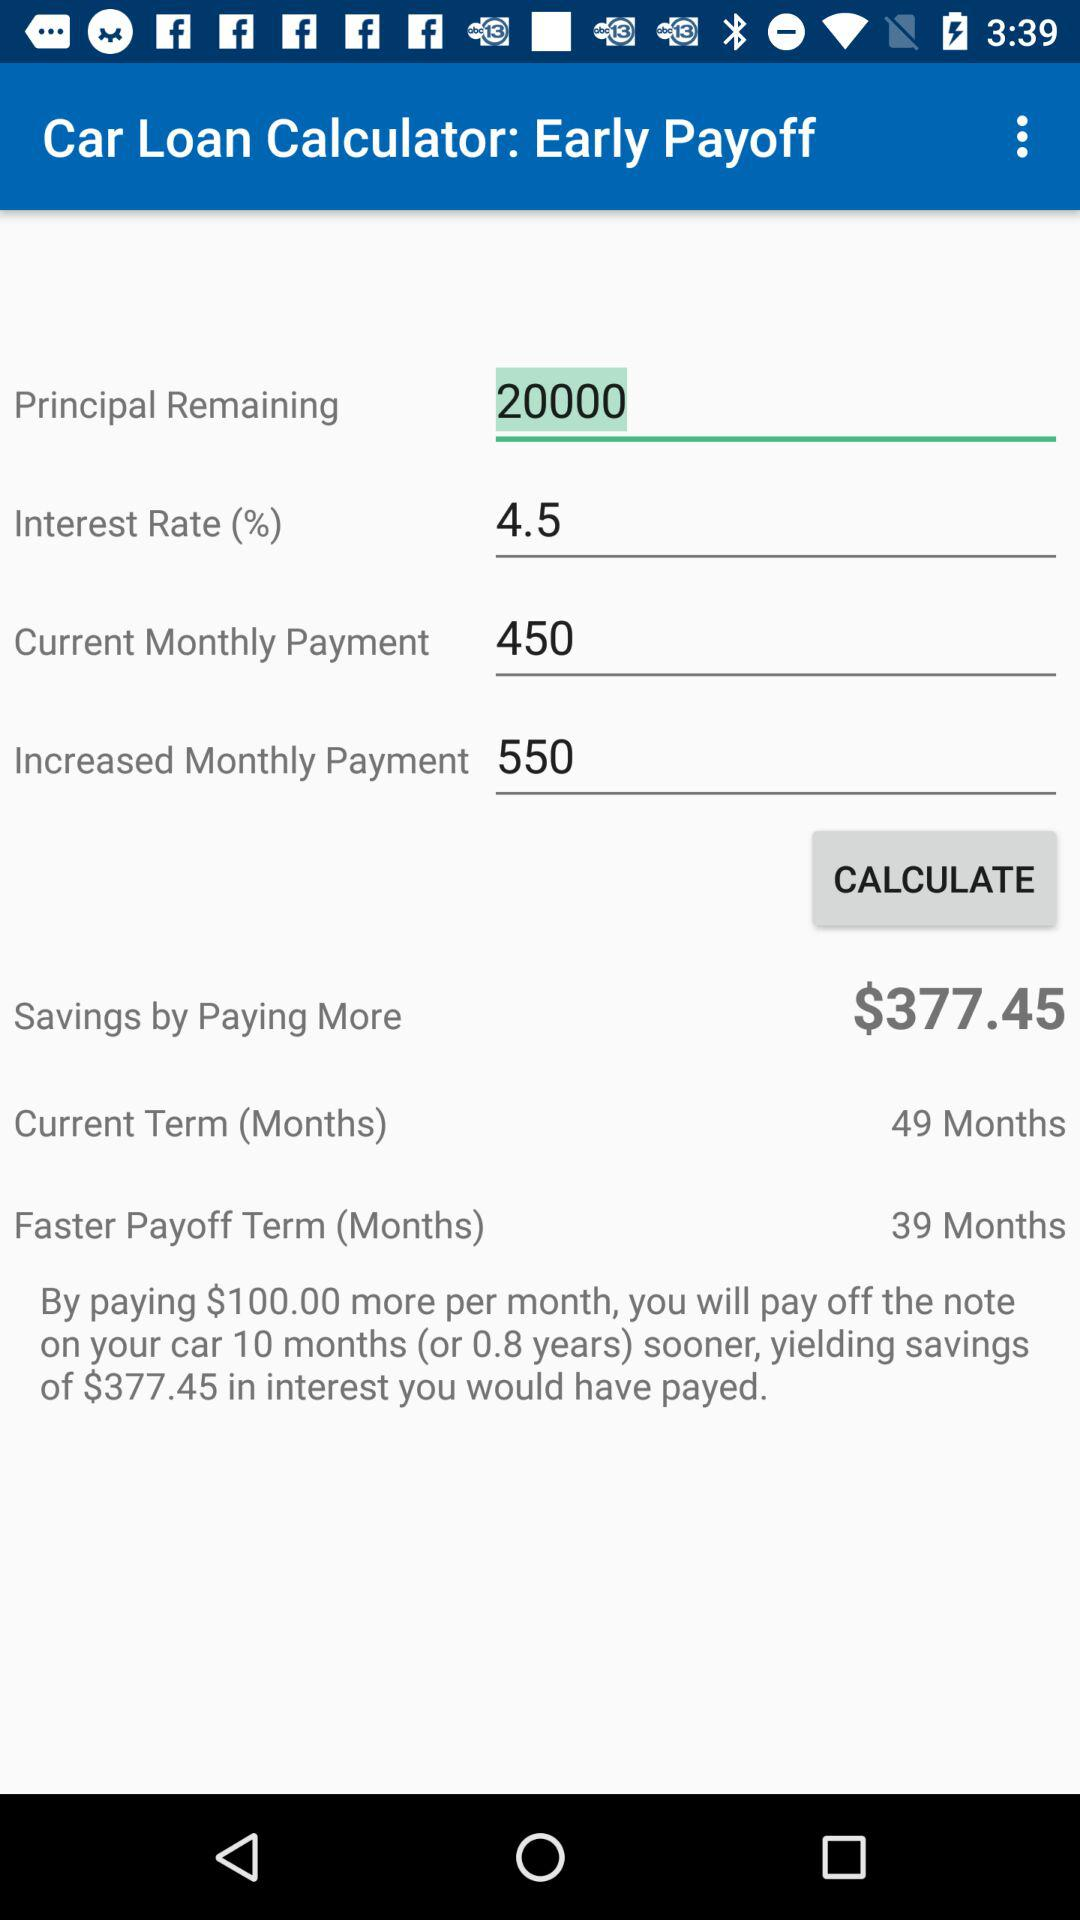What is the interest rate? The interest rate is 4.5. 